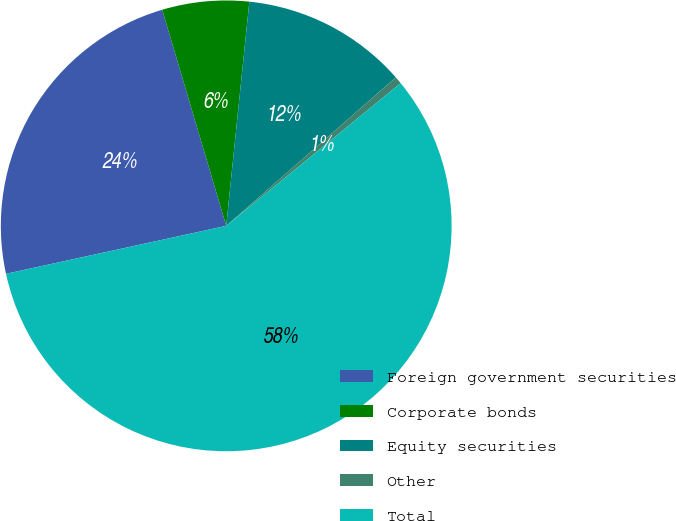Convert chart to OTSL. <chart><loc_0><loc_0><loc_500><loc_500><pie_chart><fcel>Foreign government securities<fcel>Corporate bonds<fcel>Equity securities<fcel>Other<fcel>Total<nl><fcel>23.83%<fcel>6.22%<fcel>11.92%<fcel>0.53%<fcel>57.5%<nl></chart> 